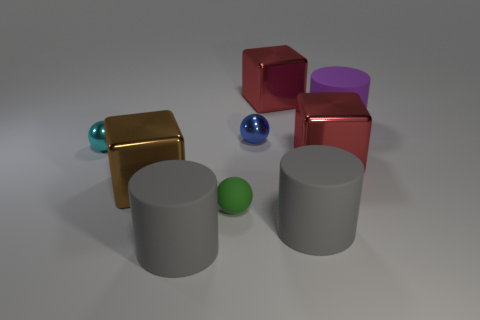Subtract all cylinders. How many objects are left? 6 Subtract 0 cyan cylinders. How many objects are left? 9 Subtract all cylinders. Subtract all cyan things. How many objects are left? 5 Add 2 cyan balls. How many cyan balls are left? 3 Add 4 blue things. How many blue things exist? 5 